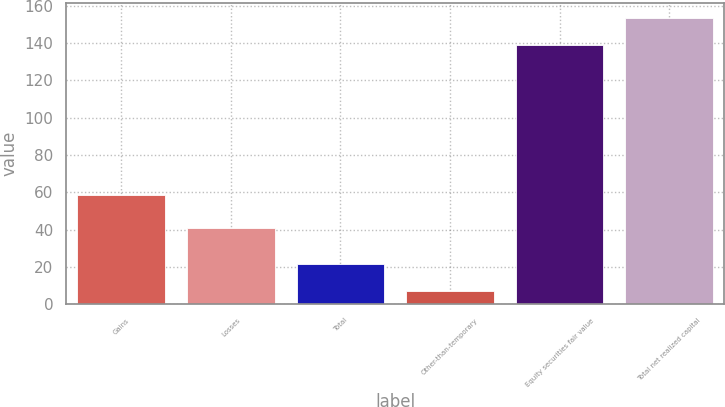Convert chart. <chart><loc_0><loc_0><loc_500><loc_500><bar_chart><fcel>Gains<fcel>Losses<fcel>Total<fcel>Other-than-temporary<fcel>Equity securities fair value<fcel>Total net realized capital<nl><fcel>58.6<fcel>40.9<fcel>21.71<fcel>7.1<fcel>139<fcel>153.61<nl></chart> 